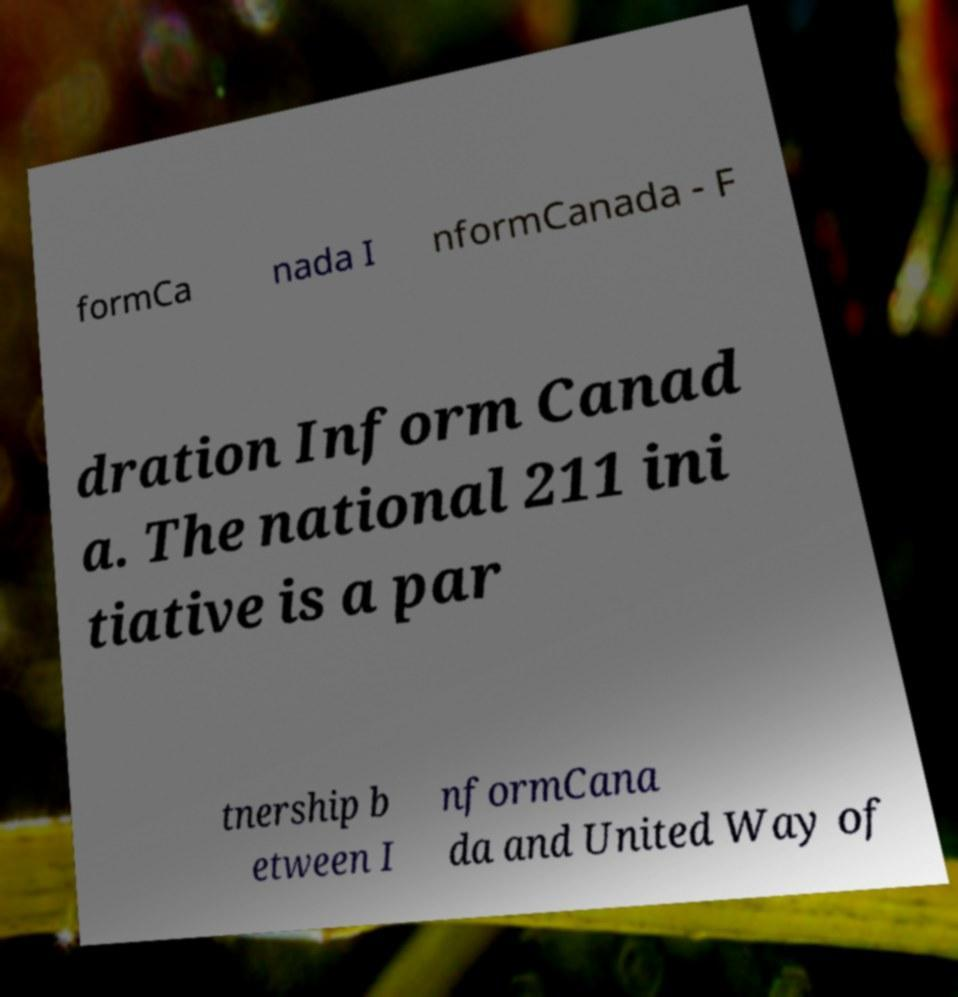Please read and relay the text visible in this image. What does it say? formCa nada I nformCanada - F dration Inform Canad a. The national 211 ini tiative is a par tnership b etween I nformCana da and United Way of 